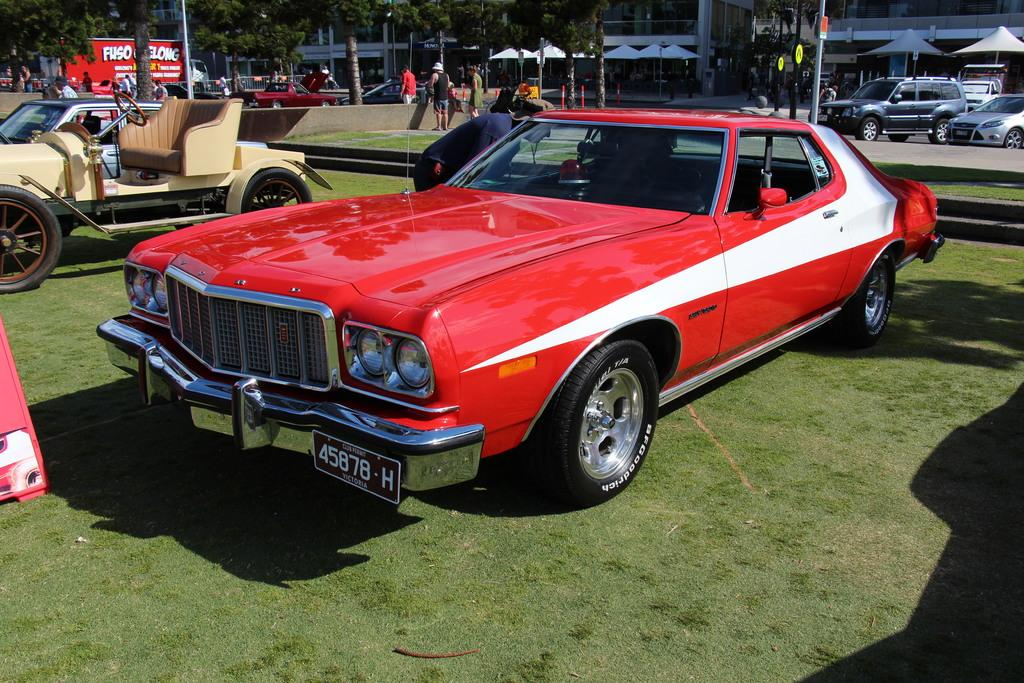What is the main subject in the center of the image? There is a car in the center of the image. Are there any other cars visible in the image? Yes, there are other cars in the top right side of the image. What can be seen in the top right side of the image besides the cars? There are trees at the top right side of the image. How many legs does the car in the center of the image have? Cars do not have legs; they have wheels for movement. The car in the image has four wheels. 